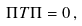Convert formula to latex. <formula><loc_0><loc_0><loc_500><loc_500>\Pi T \Pi = 0 \, ,</formula> 